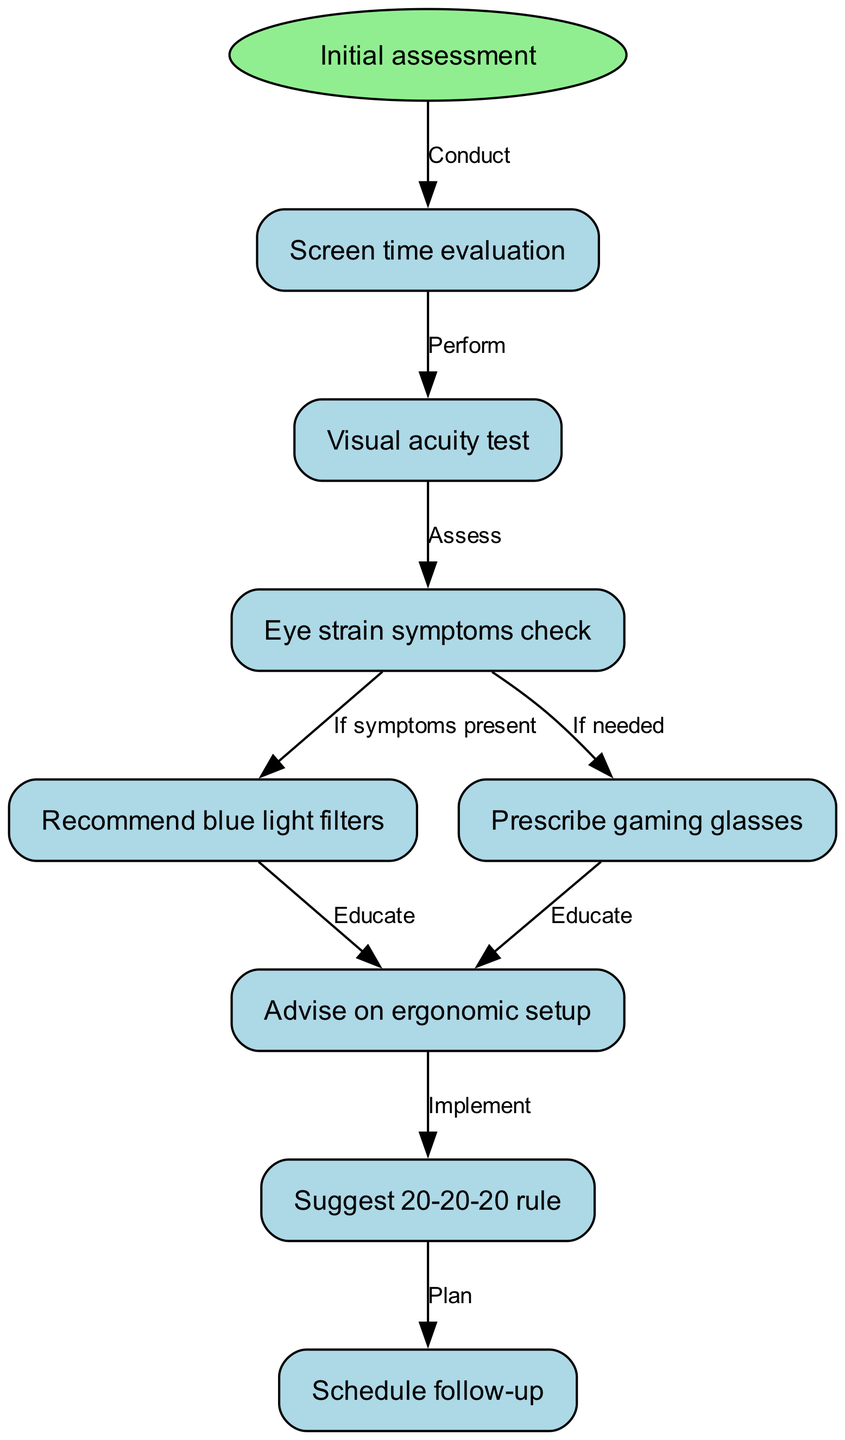What is the first action in the clinical pathway? The first action in the clinical pathway is represented by the start node labeled "Initial assessment." This is indicated by the direct connection from the start node to the first action node in the diagram.
Answer: Initial assessment How many nodes are present in the diagram? The diagram contains a total of 8 nodes, including the initial assessment. This can be counted by reviewing the node list and recognizing each individual step in the pathway.
Answer: 8 What do you do after checking for eye strain symptoms? After checking for eye strain symptoms, if symptoms are present, the next step is to recommend blue light filters. This is shown in the diagram with the conditional arrow from the symptoms check to the blue light filters recommendation.
Answer: Recommend blue light filters Which node is reached after performing a visual acuity test? After performing a visual acuity test, the next node reached is the eye strain symptoms check. This sequence is depicted with a direct edge connecting the visual acuity test node to the symptoms check node in the diagram.
Answer: Eye strain symptoms check What is the final step in the clinical pathway? The final step in the clinical pathway is to schedule a follow-up. This is shown as the last node that connects to the preceding action of implementing the 20-20-20 rule.
Answer: Schedule follow-up If a patient does not have symptoms of eye strain, what is the next recommended action? If a patient does not have symptoms of eye strain, the next recommended action would be to prescribe gaming glasses, as indicated by the edge from the symptoms check node leading to that specific recommendation node.
Answer: Prescribe gaming glasses What is advised to be implemented after an ergonomic setup? After advising on ergonomic setup, it is suggested to implement the 20-20-20 rule. This follows the logical flow in the diagram that connects ergonomic advice to the implementation step.
Answer: Suggest 20-20-20 rule What is the connection type between "recommend blue light filters" and "advise on ergonomic setup"? The connection between "recommend blue light filters" and "advise on ergonomic setup" is an educational one, as indicated in the diagram. This connection signifies that educating the patient is a follow-up action after recommending blue light filters.
Answer: Educate 